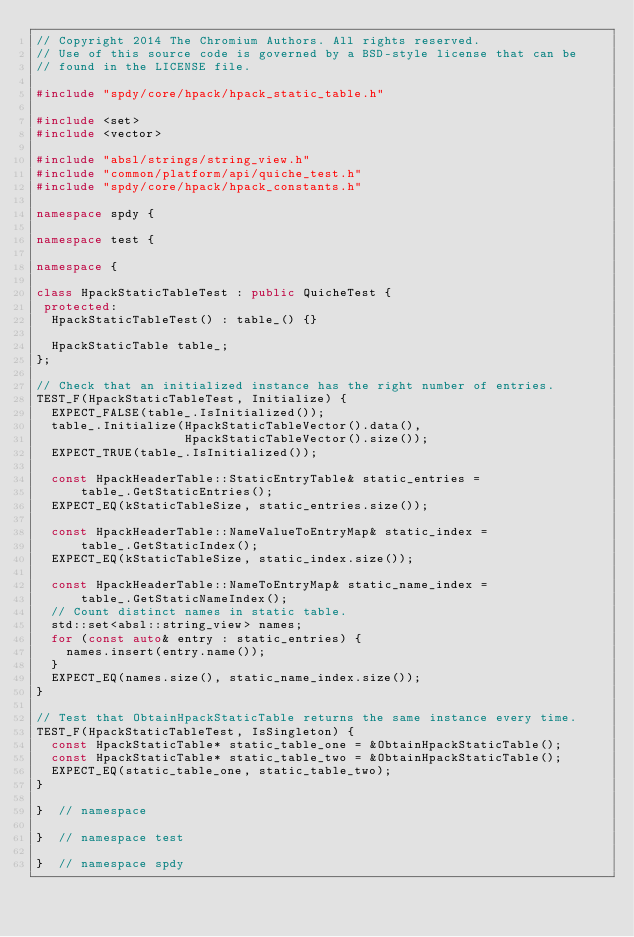Convert code to text. <code><loc_0><loc_0><loc_500><loc_500><_C++_>// Copyright 2014 The Chromium Authors. All rights reserved.
// Use of this source code is governed by a BSD-style license that can be
// found in the LICENSE file.

#include "spdy/core/hpack/hpack_static_table.h"

#include <set>
#include <vector>

#include "absl/strings/string_view.h"
#include "common/platform/api/quiche_test.h"
#include "spdy/core/hpack/hpack_constants.h"

namespace spdy {

namespace test {

namespace {

class HpackStaticTableTest : public QuicheTest {
 protected:
  HpackStaticTableTest() : table_() {}

  HpackStaticTable table_;
};

// Check that an initialized instance has the right number of entries.
TEST_F(HpackStaticTableTest, Initialize) {
  EXPECT_FALSE(table_.IsInitialized());
  table_.Initialize(HpackStaticTableVector().data(),
                    HpackStaticTableVector().size());
  EXPECT_TRUE(table_.IsInitialized());

  const HpackHeaderTable::StaticEntryTable& static_entries =
      table_.GetStaticEntries();
  EXPECT_EQ(kStaticTableSize, static_entries.size());

  const HpackHeaderTable::NameValueToEntryMap& static_index =
      table_.GetStaticIndex();
  EXPECT_EQ(kStaticTableSize, static_index.size());

  const HpackHeaderTable::NameToEntryMap& static_name_index =
      table_.GetStaticNameIndex();
  // Count distinct names in static table.
  std::set<absl::string_view> names;
  for (const auto& entry : static_entries) {
    names.insert(entry.name());
  }
  EXPECT_EQ(names.size(), static_name_index.size());
}

// Test that ObtainHpackStaticTable returns the same instance every time.
TEST_F(HpackStaticTableTest, IsSingleton) {
  const HpackStaticTable* static_table_one = &ObtainHpackStaticTable();
  const HpackStaticTable* static_table_two = &ObtainHpackStaticTable();
  EXPECT_EQ(static_table_one, static_table_two);
}

}  // namespace

}  // namespace test

}  // namespace spdy
</code> 